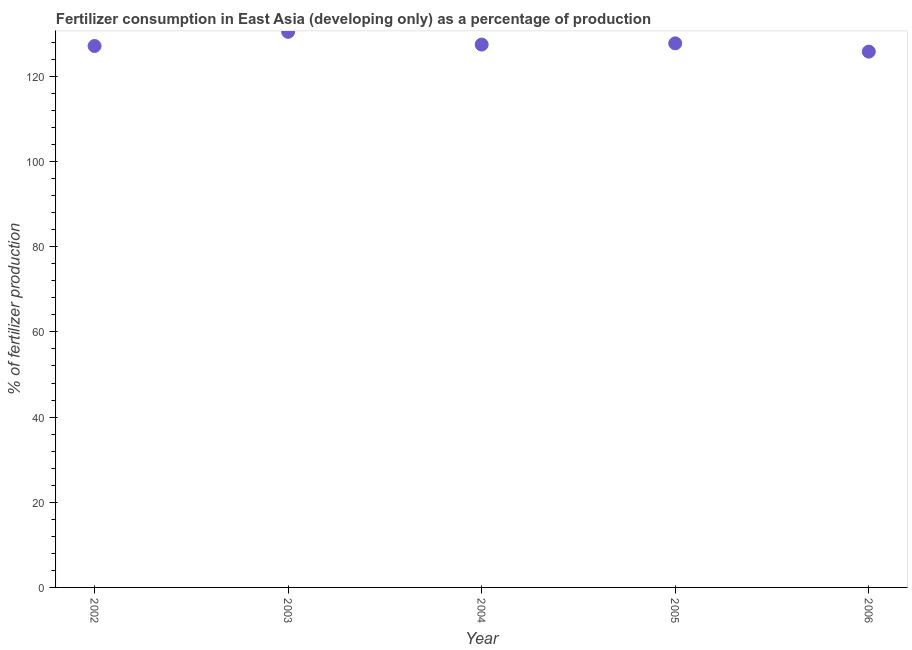What is the amount of fertilizer consumption in 2004?
Your response must be concise. 127.47. Across all years, what is the maximum amount of fertilizer consumption?
Your answer should be compact. 130.46. Across all years, what is the minimum amount of fertilizer consumption?
Provide a short and direct response. 125.81. In which year was the amount of fertilizer consumption maximum?
Ensure brevity in your answer.  2003. What is the sum of the amount of fertilizer consumption?
Your answer should be compact. 638.64. What is the difference between the amount of fertilizer consumption in 2004 and 2006?
Provide a succinct answer. 1.65. What is the average amount of fertilizer consumption per year?
Your response must be concise. 127.73. What is the median amount of fertilizer consumption?
Offer a very short reply. 127.47. What is the ratio of the amount of fertilizer consumption in 2004 to that in 2006?
Offer a terse response. 1.01. Is the amount of fertilizer consumption in 2003 less than that in 2005?
Your answer should be compact. No. Is the difference between the amount of fertilizer consumption in 2002 and 2004 greater than the difference between any two years?
Offer a terse response. No. What is the difference between the highest and the second highest amount of fertilizer consumption?
Your response must be concise. 2.71. Is the sum of the amount of fertilizer consumption in 2004 and 2005 greater than the maximum amount of fertilizer consumption across all years?
Offer a very short reply. Yes. What is the difference between the highest and the lowest amount of fertilizer consumption?
Your answer should be very brief. 4.65. Does the amount of fertilizer consumption monotonically increase over the years?
Your answer should be very brief. No. How many years are there in the graph?
Offer a terse response. 5. Does the graph contain any zero values?
Your answer should be very brief. No. What is the title of the graph?
Provide a short and direct response. Fertilizer consumption in East Asia (developing only) as a percentage of production. What is the label or title of the X-axis?
Keep it short and to the point. Year. What is the label or title of the Y-axis?
Ensure brevity in your answer.  % of fertilizer production. What is the % of fertilizer production in 2002?
Offer a terse response. 127.14. What is the % of fertilizer production in 2003?
Keep it short and to the point. 130.46. What is the % of fertilizer production in 2004?
Offer a very short reply. 127.47. What is the % of fertilizer production in 2005?
Provide a succinct answer. 127.76. What is the % of fertilizer production in 2006?
Provide a short and direct response. 125.81. What is the difference between the % of fertilizer production in 2002 and 2003?
Make the answer very short. -3.33. What is the difference between the % of fertilizer production in 2002 and 2004?
Provide a succinct answer. -0.33. What is the difference between the % of fertilizer production in 2002 and 2005?
Offer a very short reply. -0.62. What is the difference between the % of fertilizer production in 2002 and 2006?
Provide a short and direct response. 1.32. What is the difference between the % of fertilizer production in 2003 and 2004?
Keep it short and to the point. 3. What is the difference between the % of fertilizer production in 2003 and 2005?
Offer a very short reply. 2.71. What is the difference between the % of fertilizer production in 2003 and 2006?
Offer a terse response. 4.65. What is the difference between the % of fertilizer production in 2004 and 2005?
Offer a terse response. -0.29. What is the difference between the % of fertilizer production in 2004 and 2006?
Provide a succinct answer. 1.65. What is the difference between the % of fertilizer production in 2005 and 2006?
Your response must be concise. 1.94. What is the ratio of the % of fertilizer production in 2002 to that in 2003?
Your answer should be very brief. 0.97. What is the ratio of the % of fertilizer production in 2002 to that in 2005?
Offer a very short reply. 0.99. What is the ratio of the % of fertilizer production in 2002 to that in 2006?
Your answer should be compact. 1.01. What is the ratio of the % of fertilizer production in 2003 to that in 2005?
Keep it short and to the point. 1.02. What is the ratio of the % of fertilizer production in 2003 to that in 2006?
Make the answer very short. 1.04. What is the ratio of the % of fertilizer production in 2004 to that in 2005?
Give a very brief answer. 1. What is the ratio of the % of fertilizer production in 2004 to that in 2006?
Keep it short and to the point. 1.01. 